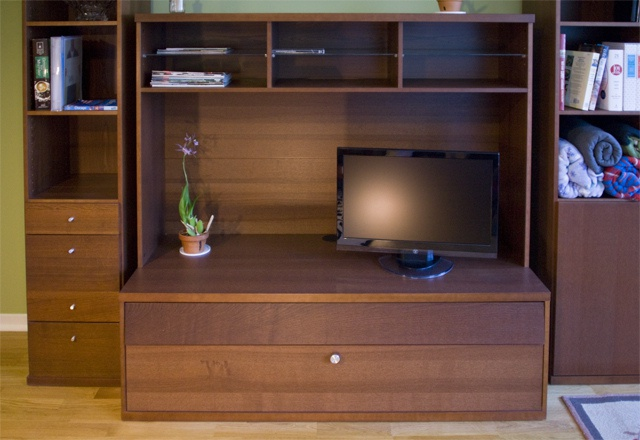Describe the objects in this image and their specific colors. I can see tv in olive, black, gray, and maroon tones, potted plant in olive, maroon, gray, black, and darkgreen tones, book in olive, black, darkgray, and gray tones, book in olive, black, gray, and darkgray tones, and book in olive, gray, darkgray, lavender, and black tones in this image. 